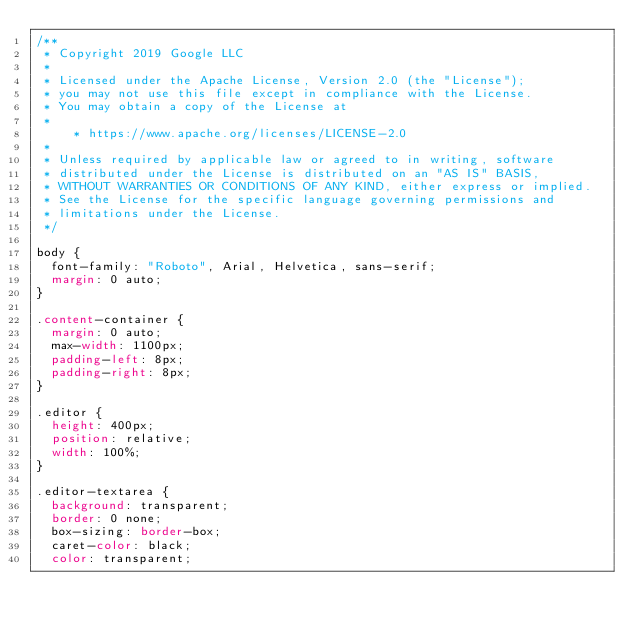<code> <loc_0><loc_0><loc_500><loc_500><_CSS_>/**
 * Copyright 2019 Google LLC
 *
 * Licensed under the Apache License, Version 2.0 (the "License");
 * you may not use this file except in compliance with the License.
 * You may obtain a copy of the License at
 *
     * https://www.apache.org/licenses/LICENSE-2.0
 *
 * Unless required by applicable law or agreed to in writing, software
 * distributed under the License is distributed on an "AS IS" BASIS,
 * WITHOUT WARRANTIES OR CONDITIONS OF ANY KIND, either express or implied.
 * See the License for the specific language governing permissions and
 * limitations under the License.
 */

body {
  font-family: "Roboto", Arial, Helvetica, sans-serif;
  margin: 0 auto;
}

.content-container {
  margin: 0 auto;
  max-width: 1100px;
  padding-left: 8px;
  padding-right: 8px;
}

.editor {
  height: 400px;
  position: relative;
  width: 100%;
}

.editor-textarea {
  background: transparent;
  border: 0 none;
  box-sizing: border-box;
  caret-color: black;
  color: transparent;</code> 